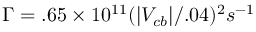<formula> <loc_0><loc_0><loc_500><loc_500>\Gamma = . 6 5 \times 1 0 ^ { 1 1 } ( | V _ { c b } | / . 0 4 ) ^ { 2 } s ^ { - 1 }</formula> 